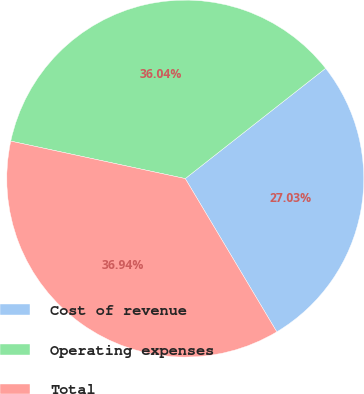Convert chart. <chart><loc_0><loc_0><loc_500><loc_500><pie_chart><fcel>Cost of revenue<fcel>Operating expenses<fcel>Total<nl><fcel>27.03%<fcel>36.04%<fcel>36.94%<nl></chart> 